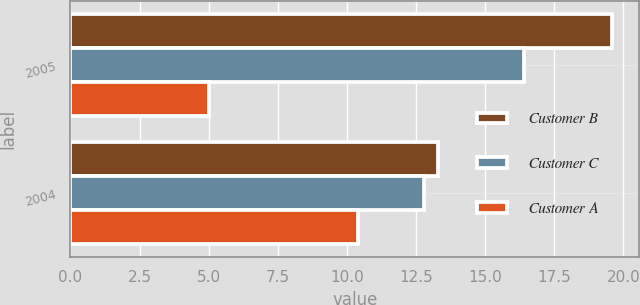Convert chart. <chart><loc_0><loc_0><loc_500><loc_500><stacked_bar_chart><ecel><fcel>2005<fcel>2004<nl><fcel>Customer B<fcel>19.6<fcel>13.3<nl><fcel>Customer C<fcel>16.4<fcel>12.8<nl><fcel>Customer A<fcel>5<fcel>10.4<nl></chart> 